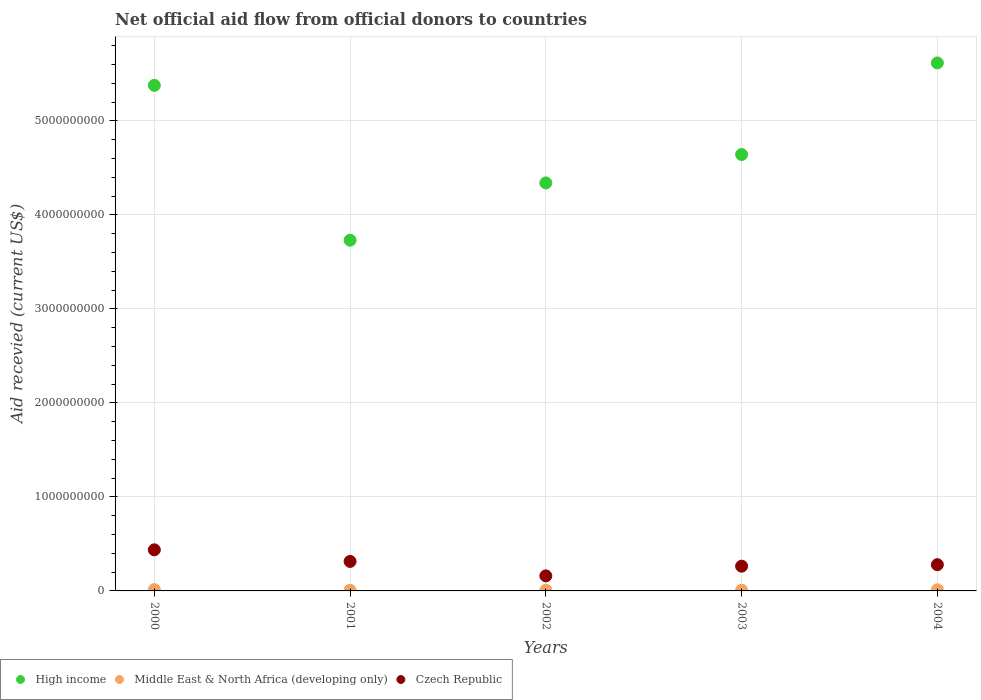What is the total aid received in High income in 2000?
Keep it short and to the point. 5.38e+09. Across all years, what is the maximum total aid received in High income?
Give a very brief answer. 5.62e+09. Across all years, what is the minimum total aid received in Middle East & North Africa (developing only)?
Keep it short and to the point. 6.88e+06. In which year was the total aid received in Middle East & North Africa (developing only) maximum?
Make the answer very short. 2000. What is the total total aid received in Middle East & North Africa (developing only) in the graph?
Your response must be concise. 4.82e+07. What is the difference between the total aid received in Middle East & North Africa (developing only) in 2000 and that in 2003?
Provide a succinct answer. 5.80e+06. What is the difference between the total aid received in High income in 2002 and the total aid received in Czech Republic in 2001?
Provide a succinct answer. 4.03e+09. What is the average total aid received in Middle East & North Africa (developing only) per year?
Give a very brief answer. 9.63e+06. In the year 2003, what is the difference between the total aid received in Middle East & North Africa (developing only) and total aid received in High income?
Your response must be concise. -4.63e+09. In how many years, is the total aid received in Middle East & North Africa (developing only) greater than 5200000000 US$?
Your response must be concise. 0. What is the ratio of the total aid received in High income in 2001 to that in 2003?
Provide a short and direct response. 0.8. Is the difference between the total aid received in Middle East & North Africa (developing only) in 2000 and 2003 greater than the difference between the total aid received in High income in 2000 and 2003?
Keep it short and to the point. No. What is the difference between the highest and the second highest total aid received in Middle East & North Africa (developing only)?
Make the answer very short. 1.32e+06. What is the difference between the highest and the lowest total aid received in Middle East & North Africa (developing only)?
Ensure brevity in your answer.  6.87e+06. In how many years, is the total aid received in Czech Republic greater than the average total aid received in Czech Republic taken over all years?
Give a very brief answer. 2. Is it the case that in every year, the sum of the total aid received in Middle East & North Africa (developing only) and total aid received in Czech Republic  is greater than the total aid received in High income?
Your response must be concise. No. Does the total aid received in Middle East & North Africa (developing only) monotonically increase over the years?
Provide a succinct answer. No. How many dotlines are there?
Ensure brevity in your answer.  3. Are the values on the major ticks of Y-axis written in scientific E-notation?
Your answer should be compact. No. Does the graph contain any zero values?
Keep it short and to the point. No. Does the graph contain grids?
Offer a terse response. Yes. Where does the legend appear in the graph?
Ensure brevity in your answer.  Bottom left. What is the title of the graph?
Ensure brevity in your answer.  Net official aid flow from official donors to countries. Does "Sri Lanka" appear as one of the legend labels in the graph?
Your answer should be very brief. No. What is the label or title of the X-axis?
Keep it short and to the point. Years. What is the label or title of the Y-axis?
Your response must be concise. Aid recevied (current US$). What is the Aid recevied (current US$) of High income in 2000?
Offer a terse response. 5.38e+09. What is the Aid recevied (current US$) in Middle East & North Africa (developing only) in 2000?
Your response must be concise. 1.38e+07. What is the Aid recevied (current US$) in Czech Republic in 2000?
Provide a succinct answer. 4.37e+08. What is the Aid recevied (current US$) in High income in 2001?
Provide a succinct answer. 3.73e+09. What is the Aid recevied (current US$) in Middle East & North Africa (developing only) in 2001?
Make the answer very short. 7.14e+06. What is the Aid recevied (current US$) of Czech Republic in 2001?
Make the answer very short. 3.14e+08. What is the Aid recevied (current US$) of High income in 2002?
Provide a succinct answer. 4.34e+09. What is the Aid recevied (current US$) in Middle East & North Africa (developing only) in 2002?
Make the answer very short. 6.88e+06. What is the Aid recevied (current US$) in Czech Republic in 2002?
Make the answer very short. 1.60e+08. What is the Aid recevied (current US$) in High income in 2003?
Your answer should be compact. 4.64e+09. What is the Aid recevied (current US$) in Middle East & North Africa (developing only) in 2003?
Your answer should be compact. 7.95e+06. What is the Aid recevied (current US$) of Czech Republic in 2003?
Make the answer very short. 2.63e+08. What is the Aid recevied (current US$) in High income in 2004?
Make the answer very short. 5.62e+09. What is the Aid recevied (current US$) of Middle East & North Africa (developing only) in 2004?
Ensure brevity in your answer.  1.24e+07. What is the Aid recevied (current US$) in Czech Republic in 2004?
Ensure brevity in your answer.  2.79e+08. Across all years, what is the maximum Aid recevied (current US$) in High income?
Your answer should be very brief. 5.62e+09. Across all years, what is the maximum Aid recevied (current US$) of Middle East & North Africa (developing only)?
Offer a very short reply. 1.38e+07. Across all years, what is the maximum Aid recevied (current US$) in Czech Republic?
Provide a succinct answer. 4.37e+08. Across all years, what is the minimum Aid recevied (current US$) in High income?
Ensure brevity in your answer.  3.73e+09. Across all years, what is the minimum Aid recevied (current US$) of Middle East & North Africa (developing only)?
Offer a terse response. 6.88e+06. Across all years, what is the minimum Aid recevied (current US$) of Czech Republic?
Make the answer very short. 1.60e+08. What is the total Aid recevied (current US$) in High income in the graph?
Keep it short and to the point. 2.37e+1. What is the total Aid recevied (current US$) of Middle East & North Africa (developing only) in the graph?
Ensure brevity in your answer.  4.82e+07. What is the total Aid recevied (current US$) in Czech Republic in the graph?
Make the answer very short. 1.45e+09. What is the difference between the Aid recevied (current US$) in High income in 2000 and that in 2001?
Make the answer very short. 1.65e+09. What is the difference between the Aid recevied (current US$) of Middle East & North Africa (developing only) in 2000 and that in 2001?
Give a very brief answer. 6.61e+06. What is the difference between the Aid recevied (current US$) of Czech Republic in 2000 and that in 2001?
Keep it short and to the point. 1.24e+08. What is the difference between the Aid recevied (current US$) in High income in 2000 and that in 2002?
Offer a terse response. 1.04e+09. What is the difference between the Aid recevied (current US$) of Middle East & North Africa (developing only) in 2000 and that in 2002?
Provide a succinct answer. 6.87e+06. What is the difference between the Aid recevied (current US$) of Czech Republic in 2000 and that in 2002?
Your answer should be compact. 2.77e+08. What is the difference between the Aid recevied (current US$) of High income in 2000 and that in 2003?
Your response must be concise. 7.36e+08. What is the difference between the Aid recevied (current US$) of Middle East & North Africa (developing only) in 2000 and that in 2003?
Your answer should be compact. 5.80e+06. What is the difference between the Aid recevied (current US$) in Czech Republic in 2000 and that in 2003?
Make the answer very short. 1.74e+08. What is the difference between the Aid recevied (current US$) of High income in 2000 and that in 2004?
Ensure brevity in your answer.  -2.38e+08. What is the difference between the Aid recevied (current US$) of Middle East & North Africa (developing only) in 2000 and that in 2004?
Ensure brevity in your answer.  1.32e+06. What is the difference between the Aid recevied (current US$) in Czech Republic in 2000 and that in 2004?
Offer a terse response. 1.58e+08. What is the difference between the Aid recevied (current US$) of High income in 2001 and that in 2002?
Ensure brevity in your answer.  -6.10e+08. What is the difference between the Aid recevied (current US$) of Czech Republic in 2001 and that in 2002?
Keep it short and to the point. 1.54e+08. What is the difference between the Aid recevied (current US$) in High income in 2001 and that in 2003?
Provide a succinct answer. -9.11e+08. What is the difference between the Aid recevied (current US$) in Middle East & North Africa (developing only) in 2001 and that in 2003?
Offer a terse response. -8.10e+05. What is the difference between the Aid recevied (current US$) of Czech Republic in 2001 and that in 2003?
Offer a very short reply. 5.05e+07. What is the difference between the Aid recevied (current US$) in High income in 2001 and that in 2004?
Keep it short and to the point. -1.89e+09. What is the difference between the Aid recevied (current US$) in Middle East & North Africa (developing only) in 2001 and that in 2004?
Provide a succinct answer. -5.29e+06. What is the difference between the Aid recevied (current US$) of Czech Republic in 2001 and that in 2004?
Make the answer very short. 3.47e+07. What is the difference between the Aid recevied (current US$) of High income in 2002 and that in 2003?
Provide a succinct answer. -3.01e+08. What is the difference between the Aid recevied (current US$) of Middle East & North Africa (developing only) in 2002 and that in 2003?
Give a very brief answer. -1.07e+06. What is the difference between the Aid recevied (current US$) in Czech Republic in 2002 and that in 2003?
Keep it short and to the point. -1.03e+08. What is the difference between the Aid recevied (current US$) of High income in 2002 and that in 2004?
Make the answer very short. -1.28e+09. What is the difference between the Aid recevied (current US$) of Middle East & North Africa (developing only) in 2002 and that in 2004?
Your answer should be compact. -5.55e+06. What is the difference between the Aid recevied (current US$) in Czech Republic in 2002 and that in 2004?
Your answer should be very brief. -1.19e+08. What is the difference between the Aid recevied (current US$) in High income in 2003 and that in 2004?
Give a very brief answer. -9.75e+08. What is the difference between the Aid recevied (current US$) of Middle East & North Africa (developing only) in 2003 and that in 2004?
Your answer should be very brief. -4.48e+06. What is the difference between the Aid recevied (current US$) of Czech Republic in 2003 and that in 2004?
Keep it short and to the point. -1.58e+07. What is the difference between the Aid recevied (current US$) in High income in 2000 and the Aid recevied (current US$) in Middle East & North Africa (developing only) in 2001?
Offer a very short reply. 5.37e+09. What is the difference between the Aid recevied (current US$) of High income in 2000 and the Aid recevied (current US$) of Czech Republic in 2001?
Make the answer very short. 5.07e+09. What is the difference between the Aid recevied (current US$) in Middle East & North Africa (developing only) in 2000 and the Aid recevied (current US$) in Czech Republic in 2001?
Keep it short and to the point. -3.00e+08. What is the difference between the Aid recevied (current US$) in High income in 2000 and the Aid recevied (current US$) in Middle East & North Africa (developing only) in 2002?
Your answer should be compact. 5.37e+09. What is the difference between the Aid recevied (current US$) in High income in 2000 and the Aid recevied (current US$) in Czech Republic in 2002?
Keep it short and to the point. 5.22e+09. What is the difference between the Aid recevied (current US$) of Middle East & North Africa (developing only) in 2000 and the Aid recevied (current US$) of Czech Republic in 2002?
Your answer should be compact. -1.46e+08. What is the difference between the Aid recevied (current US$) of High income in 2000 and the Aid recevied (current US$) of Middle East & North Africa (developing only) in 2003?
Provide a succinct answer. 5.37e+09. What is the difference between the Aid recevied (current US$) of High income in 2000 and the Aid recevied (current US$) of Czech Republic in 2003?
Your response must be concise. 5.12e+09. What is the difference between the Aid recevied (current US$) in Middle East & North Africa (developing only) in 2000 and the Aid recevied (current US$) in Czech Republic in 2003?
Provide a short and direct response. -2.50e+08. What is the difference between the Aid recevied (current US$) of High income in 2000 and the Aid recevied (current US$) of Middle East & North Africa (developing only) in 2004?
Your answer should be very brief. 5.37e+09. What is the difference between the Aid recevied (current US$) in High income in 2000 and the Aid recevied (current US$) in Czech Republic in 2004?
Provide a succinct answer. 5.10e+09. What is the difference between the Aid recevied (current US$) of Middle East & North Africa (developing only) in 2000 and the Aid recevied (current US$) of Czech Republic in 2004?
Give a very brief answer. -2.65e+08. What is the difference between the Aid recevied (current US$) in High income in 2001 and the Aid recevied (current US$) in Middle East & North Africa (developing only) in 2002?
Ensure brevity in your answer.  3.72e+09. What is the difference between the Aid recevied (current US$) in High income in 2001 and the Aid recevied (current US$) in Czech Republic in 2002?
Your response must be concise. 3.57e+09. What is the difference between the Aid recevied (current US$) of Middle East & North Africa (developing only) in 2001 and the Aid recevied (current US$) of Czech Republic in 2002?
Give a very brief answer. -1.53e+08. What is the difference between the Aid recevied (current US$) of High income in 2001 and the Aid recevied (current US$) of Middle East & North Africa (developing only) in 2003?
Your response must be concise. 3.72e+09. What is the difference between the Aid recevied (current US$) of High income in 2001 and the Aid recevied (current US$) of Czech Republic in 2003?
Keep it short and to the point. 3.47e+09. What is the difference between the Aid recevied (current US$) in Middle East & North Africa (developing only) in 2001 and the Aid recevied (current US$) in Czech Republic in 2003?
Your answer should be very brief. -2.56e+08. What is the difference between the Aid recevied (current US$) in High income in 2001 and the Aid recevied (current US$) in Middle East & North Africa (developing only) in 2004?
Offer a terse response. 3.72e+09. What is the difference between the Aid recevied (current US$) in High income in 2001 and the Aid recevied (current US$) in Czech Republic in 2004?
Make the answer very short. 3.45e+09. What is the difference between the Aid recevied (current US$) of Middle East & North Africa (developing only) in 2001 and the Aid recevied (current US$) of Czech Republic in 2004?
Give a very brief answer. -2.72e+08. What is the difference between the Aid recevied (current US$) of High income in 2002 and the Aid recevied (current US$) of Middle East & North Africa (developing only) in 2003?
Ensure brevity in your answer.  4.33e+09. What is the difference between the Aid recevied (current US$) in High income in 2002 and the Aid recevied (current US$) in Czech Republic in 2003?
Give a very brief answer. 4.08e+09. What is the difference between the Aid recevied (current US$) of Middle East & North Africa (developing only) in 2002 and the Aid recevied (current US$) of Czech Republic in 2003?
Ensure brevity in your answer.  -2.56e+08. What is the difference between the Aid recevied (current US$) of High income in 2002 and the Aid recevied (current US$) of Middle East & North Africa (developing only) in 2004?
Give a very brief answer. 4.33e+09. What is the difference between the Aid recevied (current US$) in High income in 2002 and the Aid recevied (current US$) in Czech Republic in 2004?
Your answer should be compact. 4.06e+09. What is the difference between the Aid recevied (current US$) of Middle East & North Africa (developing only) in 2002 and the Aid recevied (current US$) of Czech Republic in 2004?
Your answer should be very brief. -2.72e+08. What is the difference between the Aid recevied (current US$) in High income in 2003 and the Aid recevied (current US$) in Middle East & North Africa (developing only) in 2004?
Your answer should be very brief. 4.63e+09. What is the difference between the Aid recevied (current US$) of High income in 2003 and the Aid recevied (current US$) of Czech Republic in 2004?
Provide a short and direct response. 4.36e+09. What is the difference between the Aid recevied (current US$) of Middle East & North Africa (developing only) in 2003 and the Aid recevied (current US$) of Czech Republic in 2004?
Make the answer very short. -2.71e+08. What is the average Aid recevied (current US$) of High income per year?
Provide a succinct answer. 4.74e+09. What is the average Aid recevied (current US$) in Middle East & North Africa (developing only) per year?
Provide a succinct answer. 9.63e+06. What is the average Aid recevied (current US$) in Czech Republic per year?
Give a very brief answer. 2.91e+08. In the year 2000, what is the difference between the Aid recevied (current US$) in High income and Aid recevied (current US$) in Middle East & North Africa (developing only)?
Your answer should be very brief. 5.37e+09. In the year 2000, what is the difference between the Aid recevied (current US$) of High income and Aid recevied (current US$) of Czech Republic?
Offer a terse response. 4.94e+09. In the year 2000, what is the difference between the Aid recevied (current US$) of Middle East & North Africa (developing only) and Aid recevied (current US$) of Czech Republic?
Provide a succinct answer. -4.24e+08. In the year 2001, what is the difference between the Aid recevied (current US$) of High income and Aid recevied (current US$) of Middle East & North Africa (developing only)?
Provide a succinct answer. 3.72e+09. In the year 2001, what is the difference between the Aid recevied (current US$) in High income and Aid recevied (current US$) in Czech Republic?
Provide a short and direct response. 3.42e+09. In the year 2001, what is the difference between the Aid recevied (current US$) of Middle East & North Africa (developing only) and Aid recevied (current US$) of Czech Republic?
Offer a very short reply. -3.07e+08. In the year 2002, what is the difference between the Aid recevied (current US$) in High income and Aid recevied (current US$) in Middle East & North Africa (developing only)?
Ensure brevity in your answer.  4.33e+09. In the year 2002, what is the difference between the Aid recevied (current US$) of High income and Aid recevied (current US$) of Czech Republic?
Your answer should be very brief. 4.18e+09. In the year 2002, what is the difference between the Aid recevied (current US$) in Middle East & North Africa (developing only) and Aid recevied (current US$) in Czech Republic?
Make the answer very short. -1.53e+08. In the year 2003, what is the difference between the Aid recevied (current US$) of High income and Aid recevied (current US$) of Middle East & North Africa (developing only)?
Your answer should be compact. 4.63e+09. In the year 2003, what is the difference between the Aid recevied (current US$) in High income and Aid recevied (current US$) in Czech Republic?
Your answer should be compact. 4.38e+09. In the year 2003, what is the difference between the Aid recevied (current US$) in Middle East & North Africa (developing only) and Aid recevied (current US$) in Czech Republic?
Provide a succinct answer. -2.55e+08. In the year 2004, what is the difference between the Aid recevied (current US$) of High income and Aid recevied (current US$) of Middle East & North Africa (developing only)?
Offer a very short reply. 5.60e+09. In the year 2004, what is the difference between the Aid recevied (current US$) in High income and Aid recevied (current US$) in Czech Republic?
Your response must be concise. 5.34e+09. In the year 2004, what is the difference between the Aid recevied (current US$) of Middle East & North Africa (developing only) and Aid recevied (current US$) of Czech Republic?
Offer a terse response. -2.67e+08. What is the ratio of the Aid recevied (current US$) of High income in 2000 to that in 2001?
Offer a very short reply. 1.44. What is the ratio of the Aid recevied (current US$) in Middle East & North Africa (developing only) in 2000 to that in 2001?
Make the answer very short. 1.93. What is the ratio of the Aid recevied (current US$) of Czech Republic in 2000 to that in 2001?
Provide a short and direct response. 1.39. What is the ratio of the Aid recevied (current US$) in High income in 2000 to that in 2002?
Your response must be concise. 1.24. What is the ratio of the Aid recevied (current US$) of Middle East & North Africa (developing only) in 2000 to that in 2002?
Make the answer very short. 2. What is the ratio of the Aid recevied (current US$) in Czech Republic in 2000 to that in 2002?
Provide a short and direct response. 2.73. What is the ratio of the Aid recevied (current US$) in High income in 2000 to that in 2003?
Keep it short and to the point. 1.16. What is the ratio of the Aid recevied (current US$) of Middle East & North Africa (developing only) in 2000 to that in 2003?
Offer a very short reply. 1.73. What is the ratio of the Aid recevied (current US$) of Czech Republic in 2000 to that in 2003?
Keep it short and to the point. 1.66. What is the ratio of the Aid recevied (current US$) of High income in 2000 to that in 2004?
Your answer should be very brief. 0.96. What is the ratio of the Aid recevied (current US$) in Middle East & North Africa (developing only) in 2000 to that in 2004?
Give a very brief answer. 1.11. What is the ratio of the Aid recevied (current US$) in Czech Republic in 2000 to that in 2004?
Ensure brevity in your answer.  1.57. What is the ratio of the Aid recevied (current US$) of High income in 2001 to that in 2002?
Offer a terse response. 0.86. What is the ratio of the Aid recevied (current US$) of Middle East & North Africa (developing only) in 2001 to that in 2002?
Offer a very short reply. 1.04. What is the ratio of the Aid recevied (current US$) of Czech Republic in 2001 to that in 2002?
Provide a succinct answer. 1.96. What is the ratio of the Aid recevied (current US$) in High income in 2001 to that in 2003?
Your answer should be very brief. 0.8. What is the ratio of the Aid recevied (current US$) in Middle East & North Africa (developing only) in 2001 to that in 2003?
Provide a succinct answer. 0.9. What is the ratio of the Aid recevied (current US$) in Czech Republic in 2001 to that in 2003?
Make the answer very short. 1.19. What is the ratio of the Aid recevied (current US$) in High income in 2001 to that in 2004?
Make the answer very short. 0.66. What is the ratio of the Aid recevied (current US$) in Middle East & North Africa (developing only) in 2001 to that in 2004?
Provide a succinct answer. 0.57. What is the ratio of the Aid recevied (current US$) of Czech Republic in 2001 to that in 2004?
Ensure brevity in your answer.  1.12. What is the ratio of the Aid recevied (current US$) of High income in 2002 to that in 2003?
Offer a very short reply. 0.94. What is the ratio of the Aid recevied (current US$) in Middle East & North Africa (developing only) in 2002 to that in 2003?
Your answer should be compact. 0.87. What is the ratio of the Aid recevied (current US$) in Czech Republic in 2002 to that in 2003?
Make the answer very short. 0.61. What is the ratio of the Aid recevied (current US$) of High income in 2002 to that in 2004?
Give a very brief answer. 0.77. What is the ratio of the Aid recevied (current US$) of Middle East & North Africa (developing only) in 2002 to that in 2004?
Offer a terse response. 0.55. What is the ratio of the Aid recevied (current US$) of Czech Republic in 2002 to that in 2004?
Provide a succinct answer. 0.57. What is the ratio of the Aid recevied (current US$) of High income in 2003 to that in 2004?
Provide a succinct answer. 0.83. What is the ratio of the Aid recevied (current US$) of Middle East & North Africa (developing only) in 2003 to that in 2004?
Provide a short and direct response. 0.64. What is the ratio of the Aid recevied (current US$) of Czech Republic in 2003 to that in 2004?
Give a very brief answer. 0.94. What is the difference between the highest and the second highest Aid recevied (current US$) in High income?
Give a very brief answer. 2.38e+08. What is the difference between the highest and the second highest Aid recevied (current US$) of Middle East & North Africa (developing only)?
Offer a very short reply. 1.32e+06. What is the difference between the highest and the second highest Aid recevied (current US$) in Czech Republic?
Keep it short and to the point. 1.24e+08. What is the difference between the highest and the lowest Aid recevied (current US$) of High income?
Your answer should be compact. 1.89e+09. What is the difference between the highest and the lowest Aid recevied (current US$) in Middle East & North Africa (developing only)?
Your response must be concise. 6.87e+06. What is the difference between the highest and the lowest Aid recevied (current US$) in Czech Republic?
Give a very brief answer. 2.77e+08. 